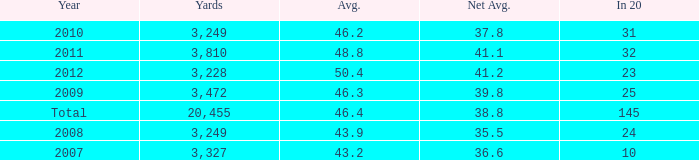What number of Yards has 32 as an In 20? 1.0. 